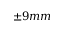<formula> <loc_0><loc_0><loc_500><loc_500>\pm 9 m m</formula> 